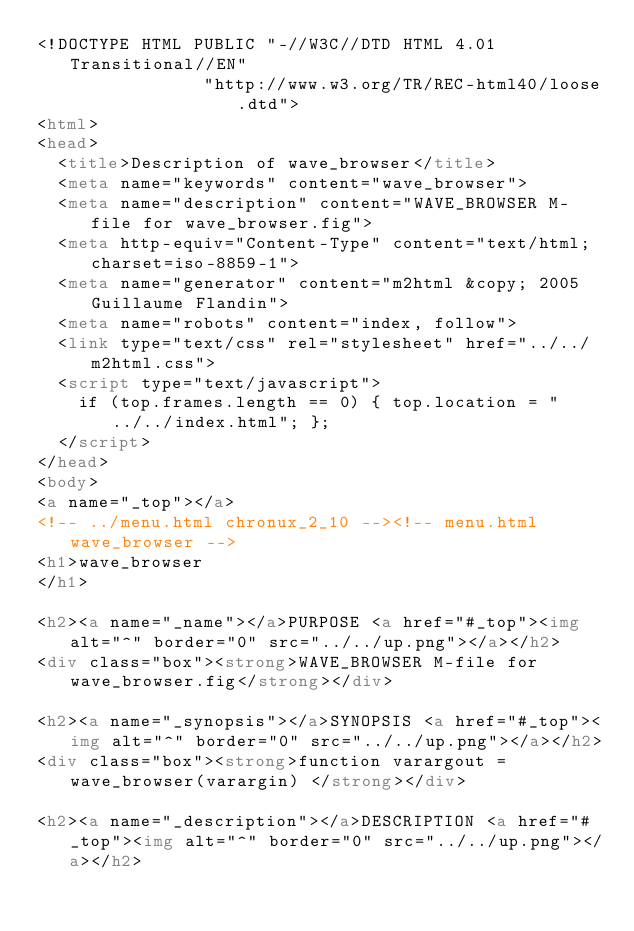<code> <loc_0><loc_0><loc_500><loc_500><_HTML_><!DOCTYPE HTML PUBLIC "-//W3C//DTD HTML 4.01 Transitional//EN"
                "http://www.w3.org/TR/REC-html40/loose.dtd">
<html>
<head>
  <title>Description of wave_browser</title>
  <meta name="keywords" content="wave_browser">
  <meta name="description" content="WAVE_BROWSER M-file for wave_browser.fig">
  <meta http-equiv="Content-Type" content="text/html; charset=iso-8859-1">
  <meta name="generator" content="m2html &copy; 2005 Guillaume Flandin">
  <meta name="robots" content="index, follow">
  <link type="text/css" rel="stylesheet" href="../../m2html.css">
  <script type="text/javascript">
    if (top.frames.length == 0) { top.location = "../../index.html"; };
  </script>
</head>
<body>
<a name="_top"></a>
<!-- ../menu.html chronux_2_10 --><!-- menu.html wave_browser -->
<h1>wave_browser
</h1>

<h2><a name="_name"></a>PURPOSE <a href="#_top"><img alt="^" border="0" src="../../up.png"></a></h2>
<div class="box"><strong>WAVE_BROWSER M-file for wave_browser.fig</strong></div>

<h2><a name="_synopsis"></a>SYNOPSIS <a href="#_top"><img alt="^" border="0" src="../../up.png"></a></h2>
<div class="box"><strong>function varargout = wave_browser(varargin) </strong></div>

<h2><a name="_description"></a>DESCRIPTION <a href="#_top"><img alt="^" border="0" src="../../up.png"></a></h2></code> 